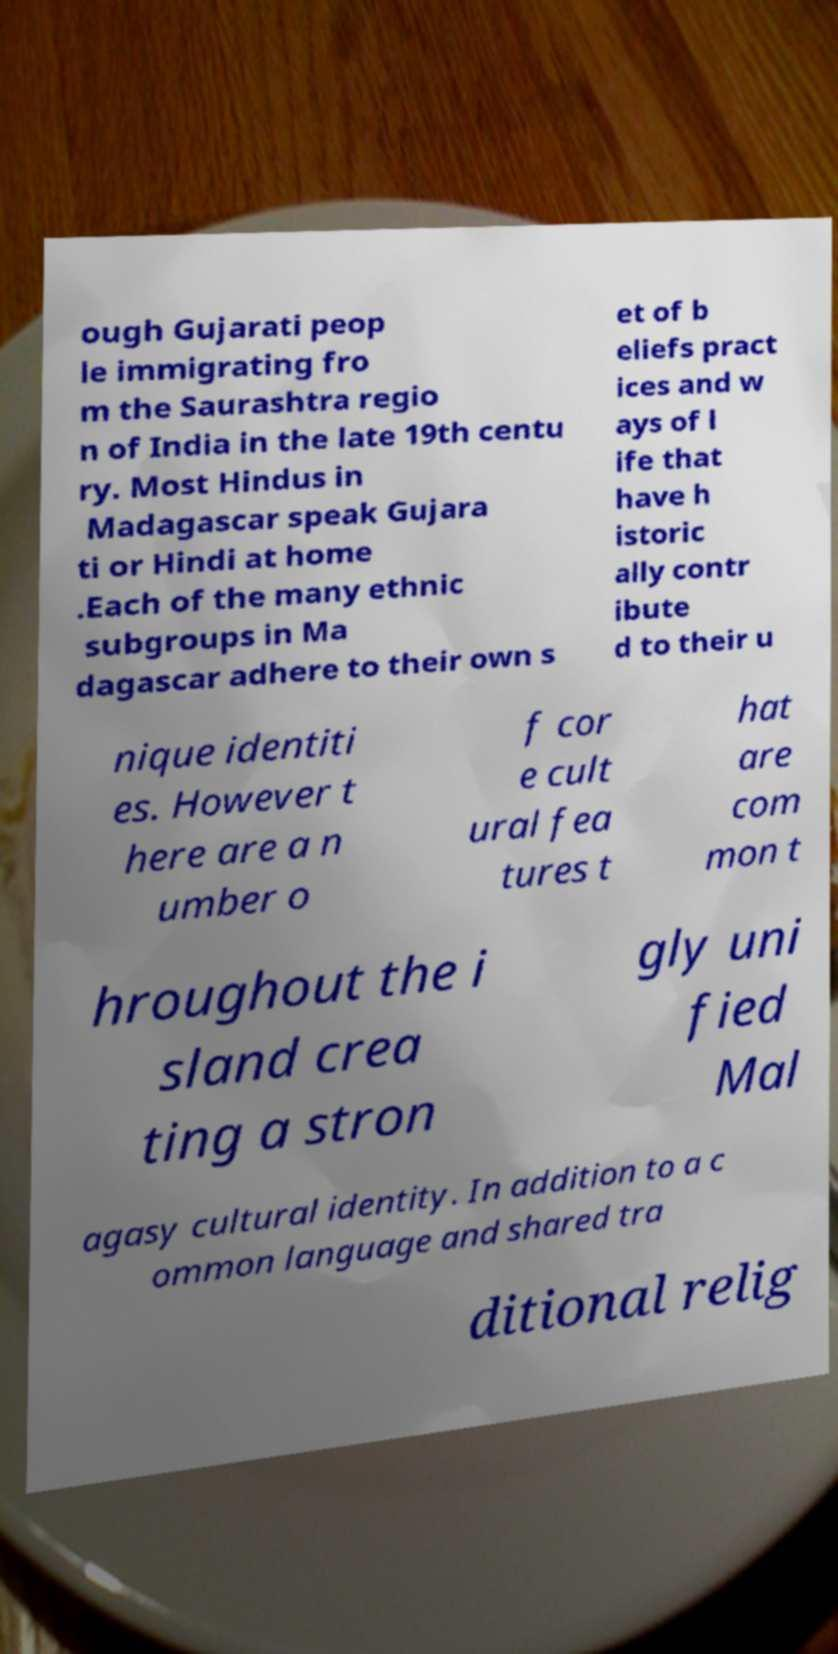What messages or text are displayed in this image? I need them in a readable, typed format. ough Gujarati peop le immigrating fro m the Saurashtra regio n of India in the late 19th centu ry. Most Hindus in Madagascar speak Gujara ti or Hindi at home .Each of the many ethnic subgroups in Ma dagascar adhere to their own s et of b eliefs pract ices and w ays of l ife that have h istoric ally contr ibute d to their u nique identiti es. However t here are a n umber o f cor e cult ural fea tures t hat are com mon t hroughout the i sland crea ting a stron gly uni fied Mal agasy cultural identity. In addition to a c ommon language and shared tra ditional relig 